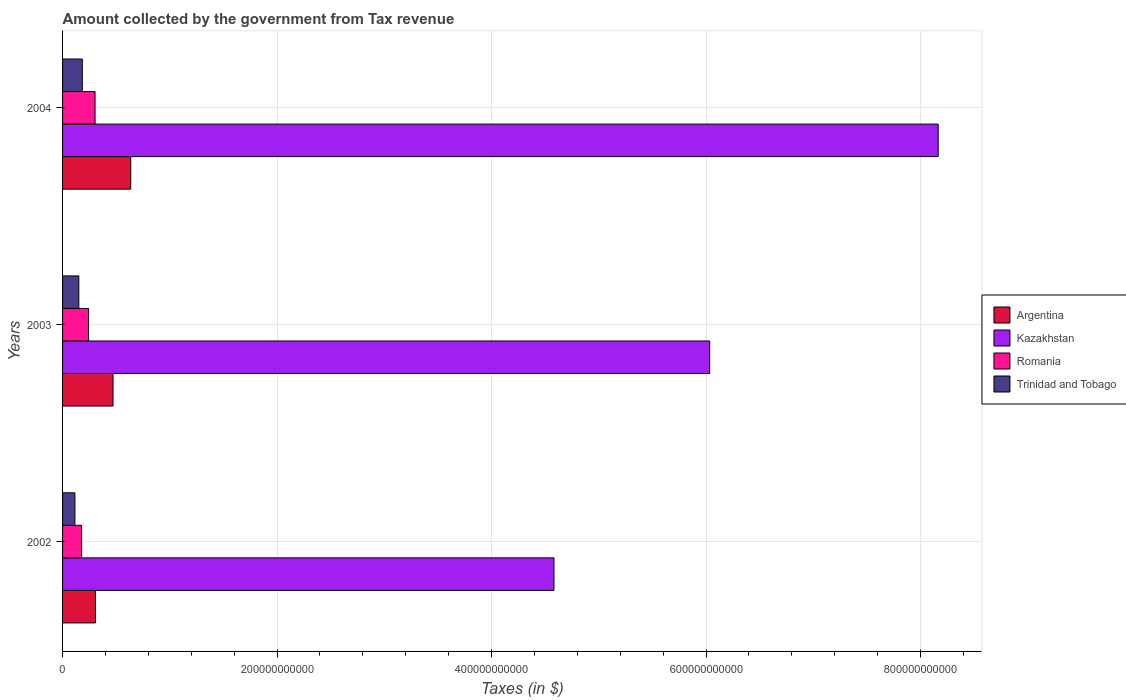How many different coloured bars are there?
Your answer should be very brief. 4. How many groups of bars are there?
Offer a terse response. 3. Are the number of bars per tick equal to the number of legend labels?
Give a very brief answer. Yes. How many bars are there on the 2nd tick from the top?
Offer a terse response. 4. How many bars are there on the 3rd tick from the bottom?
Make the answer very short. 4. In how many cases, is the number of bars for a given year not equal to the number of legend labels?
Offer a very short reply. 0. What is the amount collected by the government from tax revenue in Argentina in 2004?
Keep it short and to the point. 6.36e+1. Across all years, what is the maximum amount collected by the government from tax revenue in Romania?
Your response must be concise. 3.03e+1. Across all years, what is the minimum amount collected by the government from tax revenue in Romania?
Give a very brief answer. 1.78e+1. In which year was the amount collected by the government from tax revenue in Kazakhstan maximum?
Give a very brief answer. 2004. What is the total amount collected by the government from tax revenue in Romania in the graph?
Offer a terse response. 7.24e+1. What is the difference between the amount collected by the government from tax revenue in Trinidad and Tobago in 2002 and that in 2003?
Your answer should be compact. -3.65e+09. What is the difference between the amount collected by the government from tax revenue in Argentina in 2004 and the amount collected by the government from tax revenue in Kazakhstan in 2002?
Give a very brief answer. -3.95e+11. What is the average amount collected by the government from tax revenue in Kazakhstan per year?
Your answer should be very brief. 6.26e+11. In the year 2003, what is the difference between the amount collected by the government from tax revenue in Kazakhstan and amount collected by the government from tax revenue in Romania?
Make the answer very short. 5.79e+11. In how many years, is the amount collected by the government from tax revenue in Argentina greater than 320000000000 $?
Keep it short and to the point. 0. What is the ratio of the amount collected by the government from tax revenue in Romania in 2003 to that in 2004?
Your answer should be compact. 0.8. Is the amount collected by the government from tax revenue in Argentina in 2003 less than that in 2004?
Your answer should be compact. Yes. Is the difference between the amount collected by the government from tax revenue in Kazakhstan in 2002 and 2003 greater than the difference between the amount collected by the government from tax revenue in Romania in 2002 and 2003?
Your response must be concise. No. What is the difference between the highest and the second highest amount collected by the government from tax revenue in Argentina?
Make the answer very short. 1.65e+1. What is the difference between the highest and the lowest amount collected by the government from tax revenue in Trinidad and Tobago?
Your response must be concise. 6.91e+09. In how many years, is the amount collected by the government from tax revenue in Romania greater than the average amount collected by the government from tax revenue in Romania taken over all years?
Your response must be concise. 2. Is it the case that in every year, the sum of the amount collected by the government from tax revenue in Romania and amount collected by the government from tax revenue in Trinidad and Tobago is greater than the sum of amount collected by the government from tax revenue in Kazakhstan and amount collected by the government from tax revenue in Argentina?
Make the answer very short. No. What does the 2nd bar from the top in 2004 represents?
Offer a terse response. Romania. What does the 3rd bar from the bottom in 2003 represents?
Make the answer very short. Romania. Are all the bars in the graph horizontal?
Your answer should be very brief. Yes. How many years are there in the graph?
Provide a succinct answer. 3. What is the difference between two consecutive major ticks on the X-axis?
Keep it short and to the point. 2.00e+11. Are the values on the major ticks of X-axis written in scientific E-notation?
Your answer should be very brief. No. Does the graph contain grids?
Provide a short and direct response. Yes. How many legend labels are there?
Provide a short and direct response. 4. How are the legend labels stacked?
Your answer should be very brief. Vertical. What is the title of the graph?
Provide a succinct answer. Amount collected by the government from Tax revenue. Does "Latin America(all income levels)" appear as one of the legend labels in the graph?
Your response must be concise. No. What is the label or title of the X-axis?
Your answer should be very brief. Taxes (in $). What is the label or title of the Y-axis?
Give a very brief answer. Years. What is the Taxes (in $) in Argentina in 2002?
Keep it short and to the point. 3.07e+1. What is the Taxes (in $) of Kazakhstan in 2002?
Offer a very short reply. 4.58e+11. What is the Taxes (in $) of Romania in 2002?
Your answer should be compact. 1.78e+1. What is the Taxes (in $) in Trinidad and Tobago in 2002?
Give a very brief answer. 1.15e+1. What is the Taxes (in $) of Argentina in 2003?
Give a very brief answer. 4.71e+1. What is the Taxes (in $) in Kazakhstan in 2003?
Keep it short and to the point. 6.03e+11. What is the Taxes (in $) of Romania in 2003?
Offer a terse response. 2.43e+1. What is the Taxes (in $) of Trinidad and Tobago in 2003?
Keep it short and to the point. 1.52e+1. What is the Taxes (in $) in Argentina in 2004?
Offer a terse response. 6.36e+1. What is the Taxes (in $) in Kazakhstan in 2004?
Your response must be concise. 8.16e+11. What is the Taxes (in $) of Romania in 2004?
Your response must be concise. 3.03e+1. What is the Taxes (in $) of Trinidad and Tobago in 2004?
Your response must be concise. 1.84e+1. Across all years, what is the maximum Taxes (in $) in Argentina?
Provide a short and direct response. 6.36e+1. Across all years, what is the maximum Taxes (in $) of Kazakhstan?
Keep it short and to the point. 8.16e+11. Across all years, what is the maximum Taxes (in $) in Romania?
Give a very brief answer. 3.03e+1. Across all years, what is the maximum Taxes (in $) of Trinidad and Tobago?
Offer a very short reply. 1.84e+1. Across all years, what is the minimum Taxes (in $) in Argentina?
Your answer should be compact. 3.07e+1. Across all years, what is the minimum Taxes (in $) in Kazakhstan?
Make the answer very short. 4.58e+11. Across all years, what is the minimum Taxes (in $) of Romania?
Give a very brief answer. 1.78e+1. Across all years, what is the minimum Taxes (in $) of Trinidad and Tobago?
Your answer should be very brief. 1.15e+1. What is the total Taxes (in $) in Argentina in the graph?
Give a very brief answer. 1.41e+11. What is the total Taxes (in $) of Kazakhstan in the graph?
Offer a very short reply. 1.88e+12. What is the total Taxes (in $) of Romania in the graph?
Provide a succinct answer. 7.24e+1. What is the total Taxes (in $) in Trinidad and Tobago in the graph?
Ensure brevity in your answer.  4.51e+1. What is the difference between the Taxes (in $) of Argentina in 2002 and that in 2003?
Your answer should be compact. -1.64e+1. What is the difference between the Taxes (in $) of Kazakhstan in 2002 and that in 2003?
Provide a short and direct response. -1.45e+11. What is the difference between the Taxes (in $) in Romania in 2002 and that in 2003?
Offer a very short reply. -6.47e+09. What is the difference between the Taxes (in $) in Trinidad and Tobago in 2002 and that in 2003?
Offer a very short reply. -3.65e+09. What is the difference between the Taxes (in $) in Argentina in 2002 and that in 2004?
Make the answer very short. -3.29e+1. What is the difference between the Taxes (in $) in Kazakhstan in 2002 and that in 2004?
Keep it short and to the point. -3.58e+11. What is the difference between the Taxes (in $) of Romania in 2002 and that in 2004?
Provide a short and direct response. -1.25e+1. What is the difference between the Taxes (in $) of Trinidad and Tobago in 2002 and that in 2004?
Provide a succinct answer. -6.91e+09. What is the difference between the Taxes (in $) in Argentina in 2003 and that in 2004?
Give a very brief answer. -1.65e+1. What is the difference between the Taxes (in $) in Kazakhstan in 2003 and that in 2004?
Your response must be concise. -2.13e+11. What is the difference between the Taxes (in $) of Romania in 2003 and that in 2004?
Your answer should be very brief. -6.05e+09. What is the difference between the Taxes (in $) of Trinidad and Tobago in 2003 and that in 2004?
Your answer should be compact. -3.26e+09. What is the difference between the Taxes (in $) in Argentina in 2002 and the Taxes (in $) in Kazakhstan in 2003?
Your answer should be compact. -5.73e+11. What is the difference between the Taxes (in $) of Argentina in 2002 and the Taxes (in $) of Romania in 2003?
Your response must be concise. 6.43e+09. What is the difference between the Taxes (in $) of Argentina in 2002 and the Taxes (in $) of Trinidad and Tobago in 2003?
Offer a terse response. 1.55e+1. What is the difference between the Taxes (in $) of Kazakhstan in 2002 and the Taxes (in $) of Romania in 2003?
Your answer should be very brief. 4.34e+11. What is the difference between the Taxes (in $) of Kazakhstan in 2002 and the Taxes (in $) of Trinidad and Tobago in 2003?
Your answer should be very brief. 4.43e+11. What is the difference between the Taxes (in $) in Romania in 2002 and the Taxes (in $) in Trinidad and Tobago in 2003?
Make the answer very short. 2.62e+09. What is the difference between the Taxes (in $) of Argentina in 2002 and the Taxes (in $) of Kazakhstan in 2004?
Ensure brevity in your answer.  -7.86e+11. What is the difference between the Taxes (in $) of Argentina in 2002 and the Taxes (in $) of Romania in 2004?
Give a very brief answer. 3.84e+08. What is the difference between the Taxes (in $) of Argentina in 2002 and the Taxes (in $) of Trinidad and Tobago in 2004?
Make the answer very short. 1.23e+1. What is the difference between the Taxes (in $) of Kazakhstan in 2002 and the Taxes (in $) of Romania in 2004?
Provide a succinct answer. 4.28e+11. What is the difference between the Taxes (in $) of Kazakhstan in 2002 and the Taxes (in $) of Trinidad and Tobago in 2004?
Provide a short and direct response. 4.40e+11. What is the difference between the Taxes (in $) of Romania in 2002 and the Taxes (in $) of Trinidad and Tobago in 2004?
Provide a short and direct response. -6.40e+08. What is the difference between the Taxes (in $) in Argentina in 2003 and the Taxes (in $) in Kazakhstan in 2004?
Offer a very short reply. -7.69e+11. What is the difference between the Taxes (in $) in Argentina in 2003 and the Taxes (in $) in Romania in 2004?
Provide a short and direct response. 1.68e+1. What is the difference between the Taxes (in $) of Argentina in 2003 and the Taxes (in $) of Trinidad and Tobago in 2004?
Make the answer very short. 2.86e+1. What is the difference between the Taxes (in $) of Kazakhstan in 2003 and the Taxes (in $) of Romania in 2004?
Your response must be concise. 5.73e+11. What is the difference between the Taxes (in $) in Kazakhstan in 2003 and the Taxes (in $) in Trinidad and Tobago in 2004?
Offer a very short reply. 5.85e+11. What is the difference between the Taxes (in $) in Romania in 2003 and the Taxes (in $) in Trinidad and Tobago in 2004?
Make the answer very short. 5.83e+09. What is the average Taxes (in $) in Argentina per year?
Offer a very short reply. 4.71e+1. What is the average Taxes (in $) in Kazakhstan per year?
Offer a terse response. 6.26e+11. What is the average Taxes (in $) in Romania per year?
Offer a terse response. 2.41e+1. What is the average Taxes (in $) in Trinidad and Tobago per year?
Provide a succinct answer. 1.50e+1. In the year 2002, what is the difference between the Taxes (in $) of Argentina and Taxes (in $) of Kazakhstan?
Offer a terse response. -4.28e+11. In the year 2002, what is the difference between the Taxes (in $) of Argentina and Taxes (in $) of Romania?
Provide a short and direct response. 1.29e+1. In the year 2002, what is the difference between the Taxes (in $) of Argentina and Taxes (in $) of Trinidad and Tobago?
Your answer should be compact. 1.92e+1. In the year 2002, what is the difference between the Taxes (in $) of Kazakhstan and Taxes (in $) of Romania?
Your response must be concise. 4.40e+11. In the year 2002, what is the difference between the Taxes (in $) of Kazakhstan and Taxes (in $) of Trinidad and Tobago?
Offer a terse response. 4.47e+11. In the year 2002, what is the difference between the Taxes (in $) of Romania and Taxes (in $) of Trinidad and Tobago?
Give a very brief answer. 6.27e+09. In the year 2003, what is the difference between the Taxes (in $) of Argentina and Taxes (in $) of Kazakhstan?
Offer a terse response. -5.56e+11. In the year 2003, what is the difference between the Taxes (in $) in Argentina and Taxes (in $) in Romania?
Keep it short and to the point. 2.28e+1. In the year 2003, what is the difference between the Taxes (in $) in Argentina and Taxes (in $) in Trinidad and Tobago?
Give a very brief answer. 3.19e+1. In the year 2003, what is the difference between the Taxes (in $) in Kazakhstan and Taxes (in $) in Romania?
Provide a succinct answer. 5.79e+11. In the year 2003, what is the difference between the Taxes (in $) in Kazakhstan and Taxes (in $) in Trinidad and Tobago?
Ensure brevity in your answer.  5.88e+11. In the year 2003, what is the difference between the Taxes (in $) of Romania and Taxes (in $) of Trinidad and Tobago?
Offer a very short reply. 9.10e+09. In the year 2004, what is the difference between the Taxes (in $) of Argentina and Taxes (in $) of Kazakhstan?
Your response must be concise. -7.53e+11. In the year 2004, what is the difference between the Taxes (in $) in Argentina and Taxes (in $) in Romania?
Your response must be concise. 3.32e+1. In the year 2004, what is the difference between the Taxes (in $) of Argentina and Taxes (in $) of Trinidad and Tobago?
Your response must be concise. 4.51e+1. In the year 2004, what is the difference between the Taxes (in $) of Kazakhstan and Taxes (in $) of Romania?
Make the answer very short. 7.86e+11. In the year 2004, what is the difference between the Taxes (in $) of Kazakhstan and Taxes (in $) of Trinidad and Tobago?
Offer a terse response. 7.98e+11. In the year 2004, what is the difference between the Taxes (in $) in Romania and Taxes (in $) in Trinidad and Tobago?
Your response must be concise. 1.19e+1. What is the ratio of the Taxes (in $) of Argentina in 2002 to that in 2003?
Your answer should be compact. 0.65. What is the ratio of the Taxes (in $) in Kazakhstan in 2002 to that in 2003?
Give a very brief answer. 0.76. What is the ratio of the Taxes (in $) of Romania in 2002 to that in 2003?
Your answer should be compact. 0.73. What is the ratio of the Taxes (in $) of Trinidad and Tobago in 2002 to that in 2003?
Offer a very short reply. 0.76. What is the ratio of the Taxes (in $) of Argentina in 2002 to that in 2004?
Ensure brevity in your answer.  0.48. What is the ratio of the Taxes (in $) in Kazakhstan in 2002 to that in 2004?
Make the answer very short. 0.56. What is the ratio of the Taxes (in $) in Romania in 2002 to that in 2004?
Your answer should be compact. 0.59. What is the ratio of the Taxes (in $) of Argentina in 2003 to that in 2004?
Keep it short and to the point. 0.74. What is the ratio of the Taxes (in $) of Kazakhstan in 2003 to that in 2004?
Make the answer very short. 0.74. What is the ratio of the Taxes (in $) of Romania in 2003 to that in 2004?
Offer a very short reply. 0.8. What is the ratio of the Taxes (in $) of Trinidad and Tobago in 2003 to that in 2004?
Your answer should be compact. 0.82. What is the difference between the highest and the second highest Taxes (in $) in Argentina?
Ensure brevity in your answer.  1.65e+1. What is the difference between the highest and the second highest Taxes (in $) of Kazakhstan?
Provide a short and direct response. 2.13e+11. What is the difference between the highest and the second highest Taxes (in $) of Romania?
Keep it short and to the point. 6.05e+09. What is the difference between the highest and the second highest Taxes (in $) in Trinidad and Tobago?
Your answer should be very brief. 3.26e+09. What is the difference between the highest and the lowest Taxes (in $) of Argentina?
Provide a succinct answer. 3.29e+1. What is the difference between the highest and the lowest Taxes (in $) of Kazakhstan?
Make the answer very short. 3.58e+11. What is the difference between the highest and the lowest Taxes (in $) in Romania?
Keep it short and to the point. 1.25e+1. What is the difference between the highest and the lowest Taxes (in $) in Trinidad and Tobago?
Keep it short and to the point. 6.91e+09. 